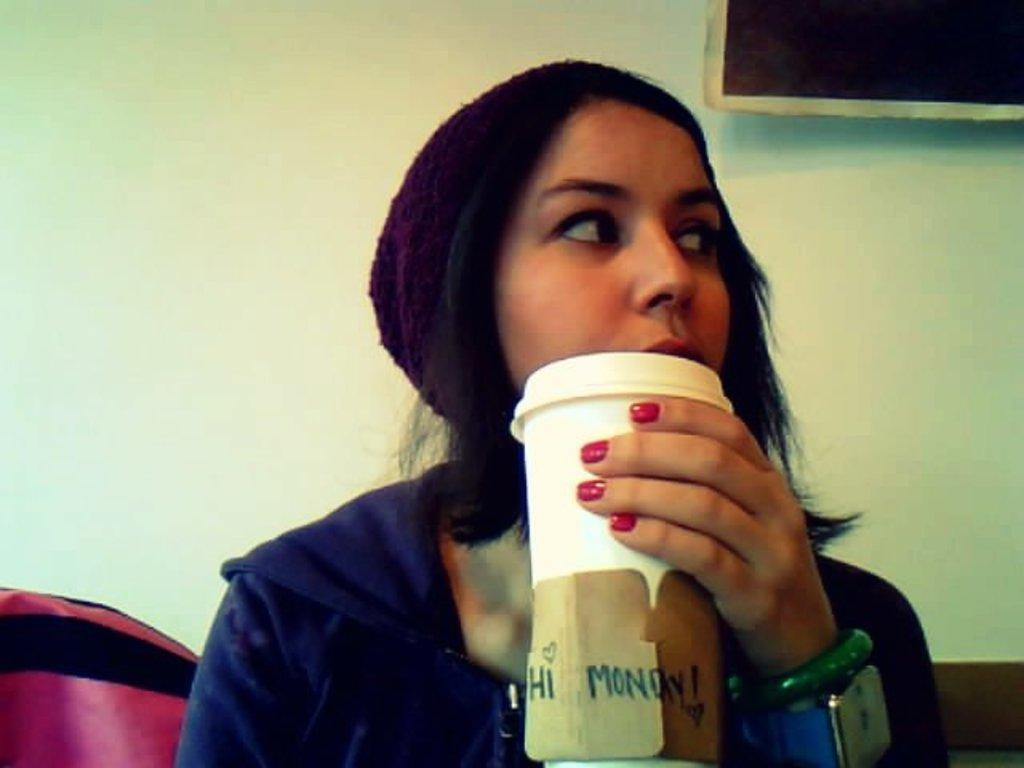What is the main subject of the image? There is a lady person in the image. What is the lady person wearing? The lady person is wearing a blue sweater. What is the lady person holding in her hands? The lady person is holding a coffee cup in her hands. What type of rock can be seen in the aftermath of the lady person's bubble? There is no rock or bubble present in the image, so it is not possible to answer that question. 